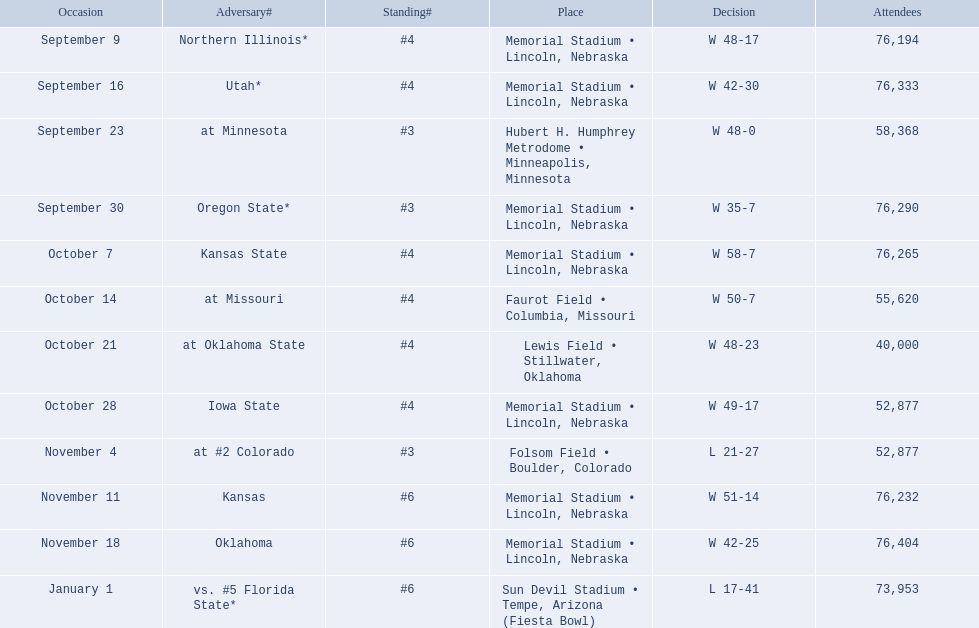Who were all of their opponents? Northern Illinois*, Utah*, at Minnesota, Oregon State*, Kansas State, at Missouri, at Oklahoma State, Iowa State, at #2 Colorado, Kansas, Oklahoma, vs. #5 Florida State*. And what was the attendance of these games? 76,194, 76,333, 58,368, 76,290, 76,265, 55,620, 40,000, 52,877, 52,877, 76,232, 76,404, 73,953. Of those numbers, which is associated with the oregon state game? 76,290. 